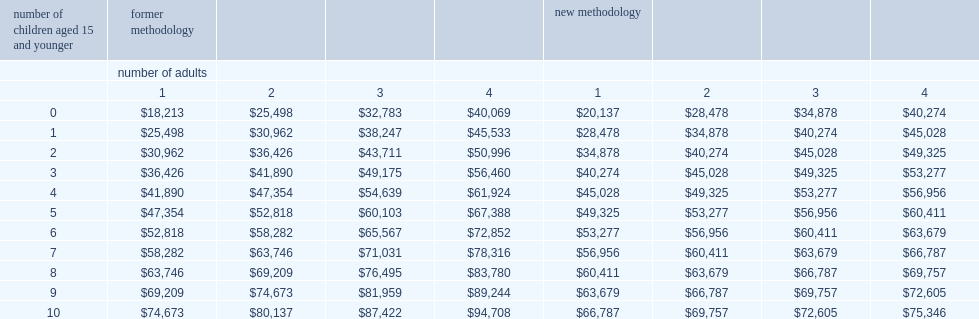Could you parse the entire table as a dict? {'header': ['number of children aged 15 and younger', 'former methodology', '', '', '', 'new methodology', '', '', ''], 'rows': [['', 'number of adults', '', '', '', '', '', '', ''], ['', '1', '2', '3', '4', '1', '2', '3', '4'], ['0', '$18,213', '$25,498', '$32,783', '$40,069', '$20,137', '$28,478', '$34,878', '$40,274'], ['1', '$25,498', '$30,962', '$38,247', '$45,533', '$28,478', '$34,878', '$40,274', '$45,028'], ['2', '$30,962', '$36,426', '$43,711', '$50,996', '$34,878', '$40,274', '$45,028', '$49,325'], ['3', '$36,426', '$41,890', '$49,175', '$56,460', '$40,274', '$45,028', '$49,325', '$53,277'], ['4', '$41,890', '$47,354', '$54,639', '$61,924', '$45,028', '$49,325', '$53,277', '$56,956'], ['5', '$47,354', '$52,818', '$60,103', '$67,388', '$49,325', '$53,277', '$56,956', '$60,411'], ['6', '$52,818', '$58,282', '$65,567', '$72,852', '$53,277', '$56,956', '$60,411', '$63,679'], ['7', '$58,282', '$63,746', '$71,031', '$78,316', '$56,956', '$60,411', '$63,679', '$66,787'], ['8', '$63,746', '$69,209', '$76,495', '$83,780', '$60,411', '$63,679', '$66,787', '$69,757'], ['9', '$69,209', '$74,673', '$81,959', '$89,244', '$63,679', '$66,787', '$69,757', '$72,605'], ['10', '$74,673', '$80,137', '$87,422', '$94,708', '$66,787', '$69,757', '$72,605', '$75,346']]} When the new method (√fsize) is used and the median is calculated for individuals rather than families, what is the threshold for the cflim-at for 2015? $20,137. What is the cflim-at threshold for individuals when the old method is used? $18,213. 